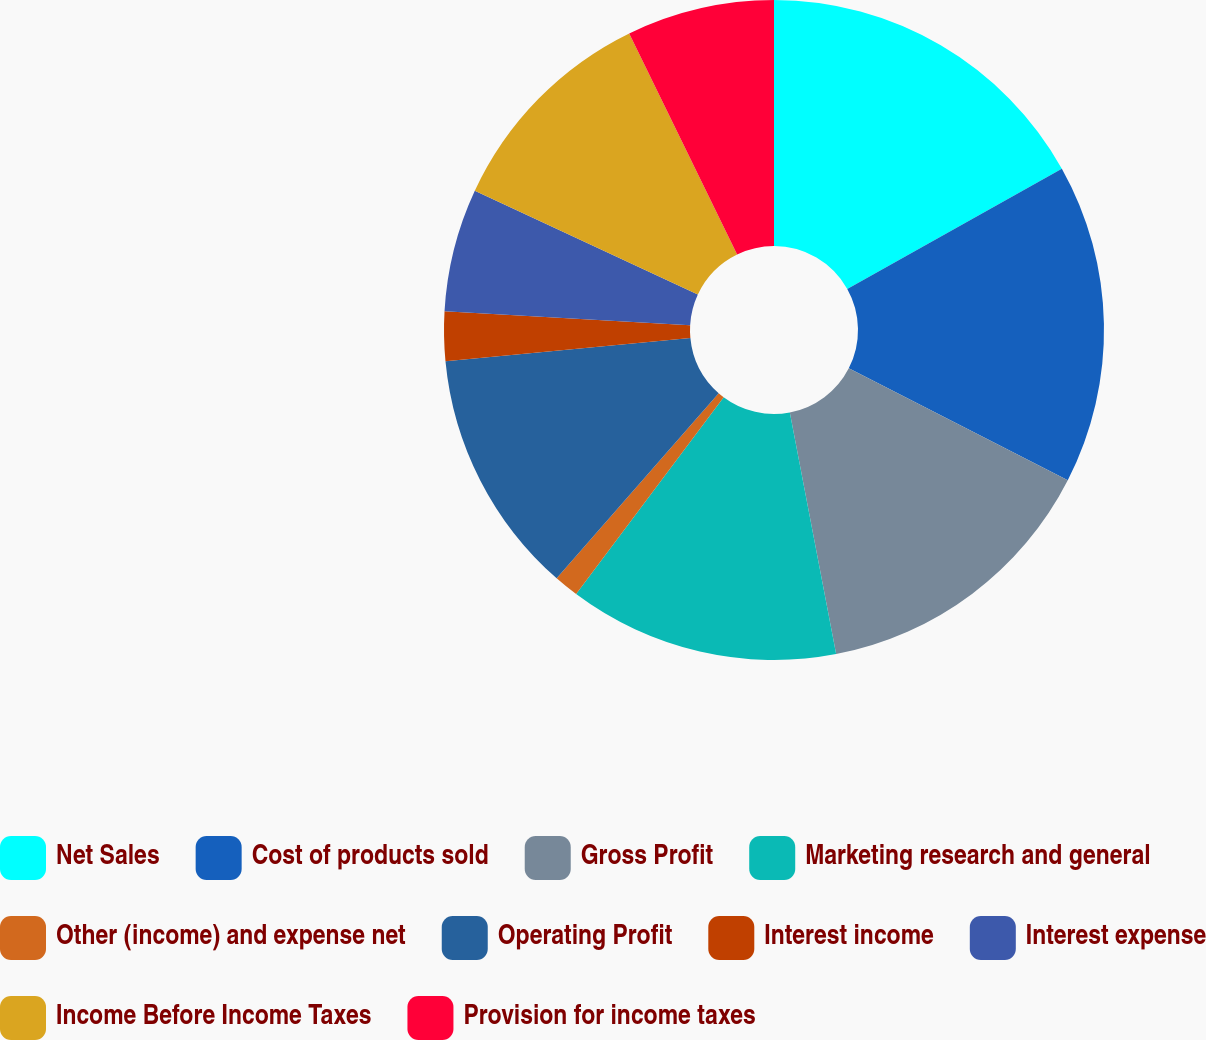<chart> <loc_0><loc_0><loc_500><loc_500><pie_chart><fcel>Net Sales<fcel>Cost of products sold<fcel>Gross Profit<fcel>Marketing research and general<fcel>Other (income) and expense net<fcel>Operating Profit<fcel>Interest income<fcel>Interest expense<fcel>Income Before Income Taxes<fcel>Provision for income taxes<nl><fcel>16.87%<fcel>15.66%<fcel>14.46%<fcel>13.25%<fcel>1.21%<fcel>12.05%<fcel>2.41%<fcel>6.03%<fcel>10.84%<fcel>7.23%<nl></chart> 